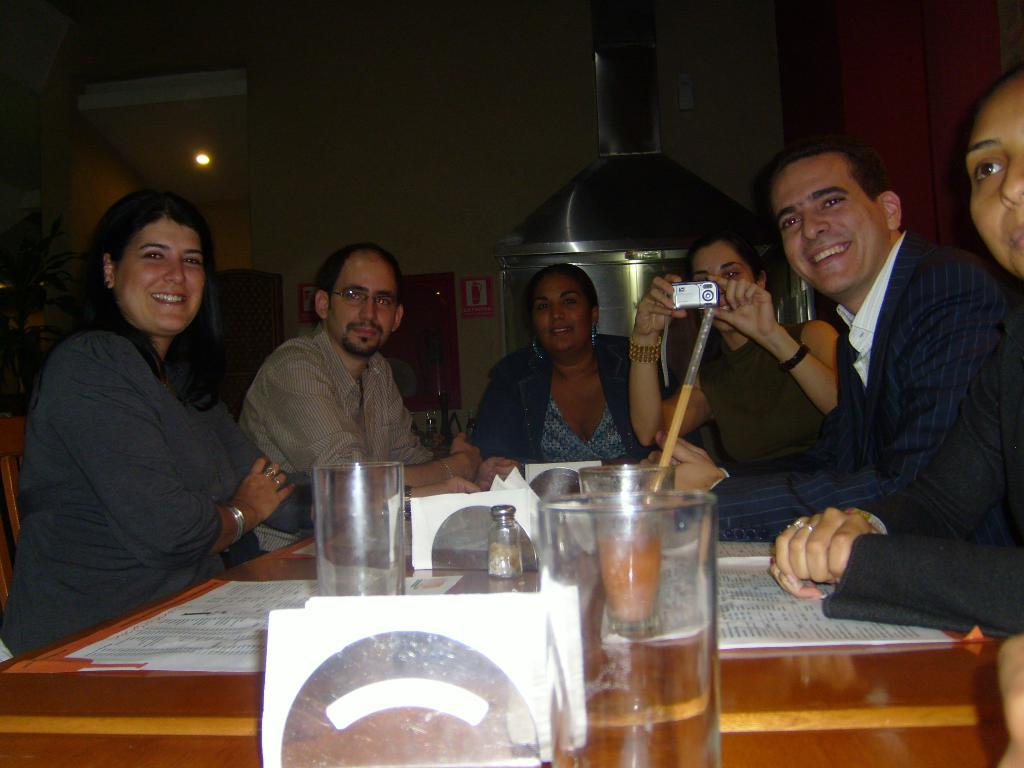What are the people in the image doing? The persons in the image are sitting around a dining table. What objects can be seen on the dining table? There are glasses, tissues, and papers on the dining table. What is visible in the background of the image? There is a chimney and lights in the background. How tall is the chimney in the image? The chimney extends to the ceiling in the image. How many giants are present in the image? There are no giants present in the image. What type of land can be seen through the window in the image? There is no window or land visible in the image. 